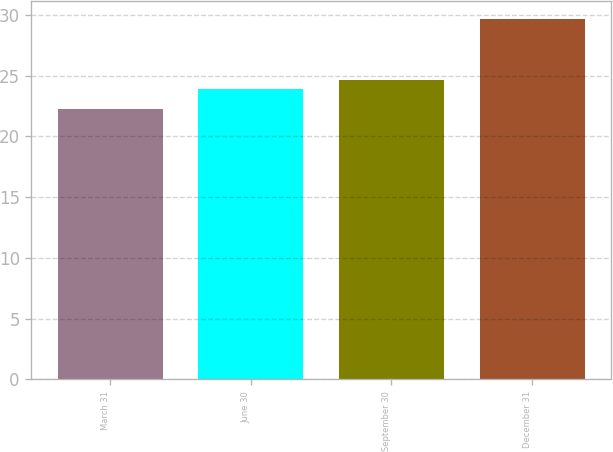Convert chart. <chart><loc_0><loc_0><loc_500><loc_500><bar_chart><fcel>March 31<fcel>June 30<fcel>September 30<fcel>December 31<nl><fcel>22.3<fcel>23.9<fcel>24.64<fcel>29.7<nl></chart> 